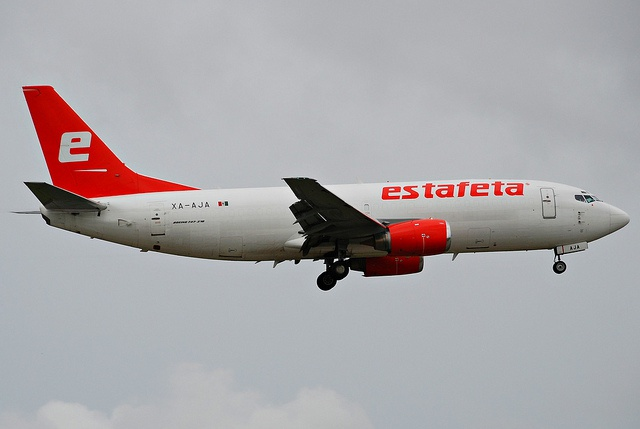Describe the objects in this image and their specific colors. I can see a airplane in darkgray, black, lightgray, and gray tones in this image. 